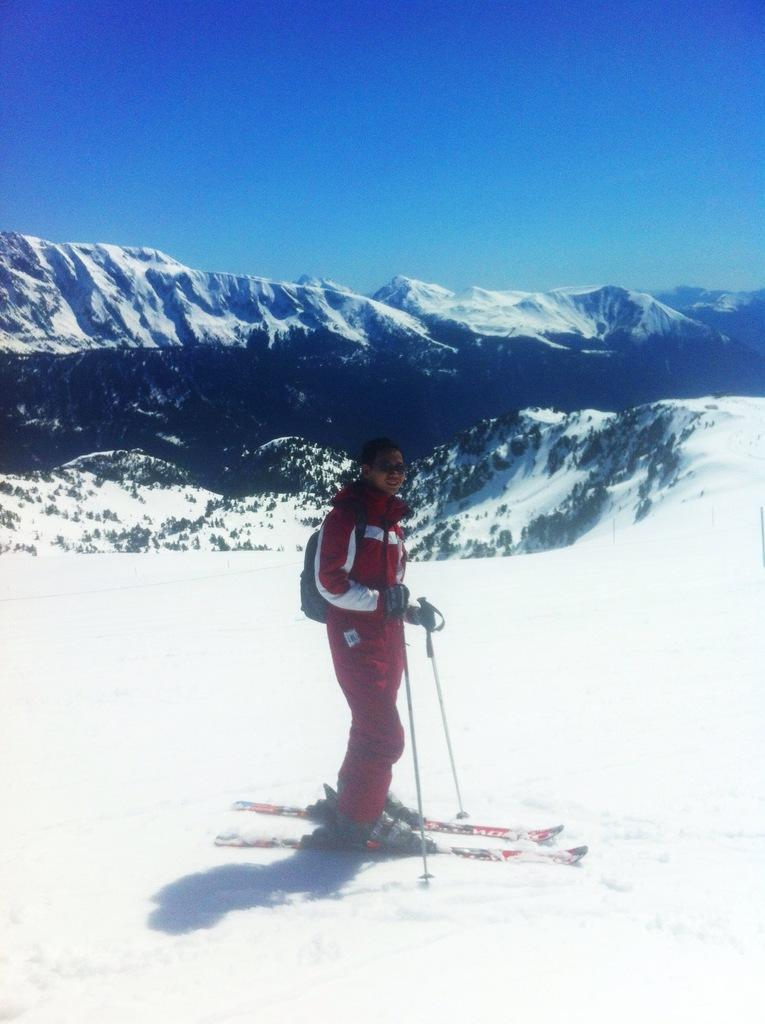What is the main subject of the image? There is a person in the image. What is the person doing in the image? The person is standing on skis and holding sticks, which are likely ski poles. What can be seen in the background of the image? The sky is visible in the background of the image. What type of bird can be seen flying in the image? There is no bird present in the image; it features a person standing on skis and holding ski poles with the sky visible in the background. 